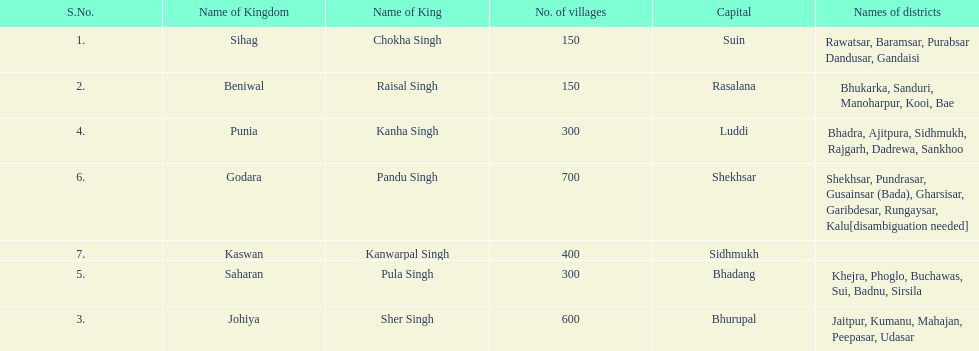Does punia have more or less villages than godara? Less. 